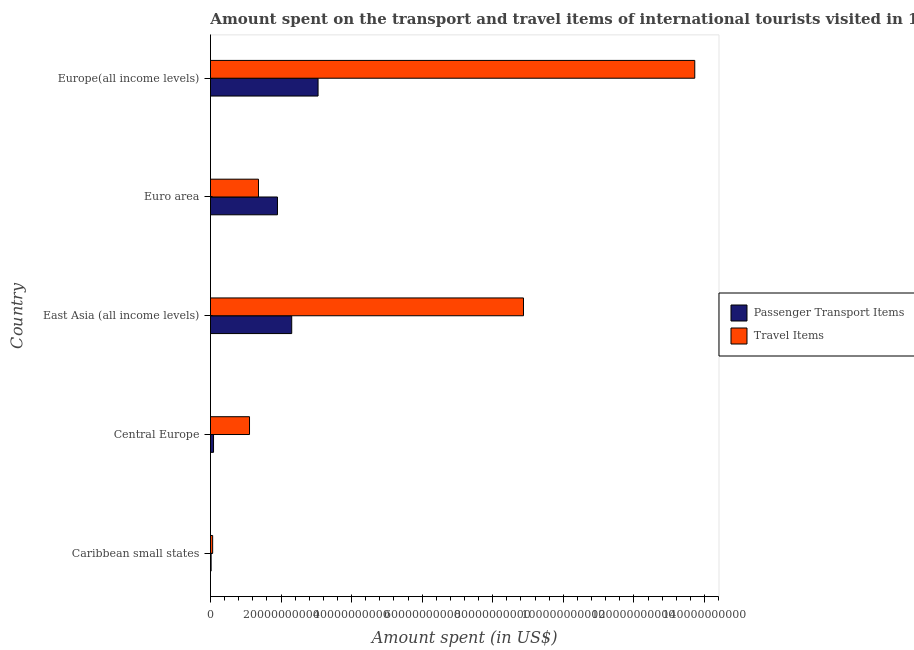How many groups of bars are there?
Ensure brevity in your answer.  5. How many bars are there on the 4th tick from the top?
Provide a short and direct response. 2. What is the label of the 4th group of bars from the top?
Offer a terse response. Central Europe. In how many cases, is the number of bars for a given country not equal to the number of legend labels?
Your response must be concise. 0. What is the amount spent in travel items in East Asia (all income levels)?
Keep it short and to the point. 8.87e+1. Across all countries, what is the maximum amount spent in travel items?
Keep it short and to the point. 1.37e+11. Across all countries, what is the minimum amount spent in travel items?
Your answer should be very brief. 6.17e+08. In which country was the amount spent in travel items maximum?
Keep it short and to the point. Europe(all income levels). In which country was the amount spent on passenger transport items minimum?
Offer a very short reply. Caribbean small states. What is the total amount spent on passenger transport items in the graph?
Keep it short and to the point. 7.35e+1. What is the difference between the amount spent in travel items in Euro area and that in Europe(all income levels)?
Your answer should be very brief. -1.24e+11. What is the difference between the amount spent on passenger transport items in Europe(all income levels) and the amount spent in travel items in Caribbean small states?
Your answer should be compact. 2.99e+1. What is the average amount spent on passenger transport items per country?
Ensure brevity in your answer.  1.47e+1. What is the difference between the amount spent in travel items and amount spent on passenger transport items in East Asia (all income levels)?
Offer a very short reply. 6.57e+1. In how many countries, is the amount spent in travel items greater than 32000000000 US$?
Offer a very short reply. 2. What is the ratio of the amount spent in travel items in East Asia (all income levels) to that in Europe(all income levels)?
Offer a terse response. 0.65. Is the difference between the amount spent on passenger transport items in Central Europe and Euro area greater than the difference between the amount spent in travel items in Central Europe and Euro area?
Keep it short and to the point. No. What is the difference between the highest and the second highest amount spent on passenger transport items?
Provide a short and direct response. 7.47e+09. What is the difference between the highest and the lowest amount spent on passenger transport items?
Keep it short and to the point. 3.03e+1. What does the 2nd bar from the top in Euro area represents?
Give a very brief answer. Passenger Transport Items. What does the 2nd bar from the bottom in Euro area represents?
Provide a short and direct response. Travel Items. How many bars are there?
Offer a very short reply. 10. Are all the bars in the graph horizontal?
Your answer should be very brief. Yes. How many countries are there in the graph?
Offer a terse response. 5. What is the difference between two consecutive major ticks on the X-axis?
Your answer should be very brief. 2.00e+1. Does the graph contain any zero values?
Your answer should be very brief. No. Does the graph contain grids?
Provide a short and direct response. No. Where does the legend appear in the graph?
Keep it short and to the point. Center right. How many legend labels are there?
Give a very brief answer. 2. How are the legend labels stacked?
Your response must be concise. Vertical. What is the title of the graph?
Give a very brief answer. Amount spent on the transport and travel items of international tourists visited in 1995. What is the label or title of the X-axis?
Your response must be concise. Amount spent (in US$). What is the label or title of the Y-axis?
Your response must be concise. Country. What is the Amount spent (in US$) in Passenger Transport Items in Caribbean small states?
Your answer should be compact. 1.79e+08. What is the Amount spent (in US$) of Travel Items in Caribbean small states?
Offer a very short reply. 6.17e+08. What is the Amount spent (in US$) of Passenger Transport Items in Central Europe?
Provide a short and direct response. 8.65e+08. What is the Amount spent (in US$) of Travel Items in Central Europe?
Offer a very short reply. 1.11e+1. What is the Amount spent (in US$) in Passenger Transport Items in East Asia (all income levels)?
Offer a terse response. 2.30e+1. What is the Amount spent (in US$) in Travel Items in East Asia (all income levels)?
Your answer should be very brief. 8.87e+1. What is the Amount spent (in US$) of Passenger Transport Items in Euro area?
Make the answer very short. 1.90e+1. What is the Amount spent (in US$) of Travel Items in Euro area?
Give a very brief answer. 1.36e+1. What is the Amount spent (in US$) of Passenger Transport Items in Europe(all income levels)?
Offer a very short reply. 3.05e+1. What is the Amount spent (in US$) of Travel Items in Europe(all income levels)?
Provide a short and direct response. 1.37e+11. Across all countries, what is the maximum Amount spent (in US$) in Passenger Transport Items?
Provide a succinct answer. 3.05e+1. Across all countries, what is the maximum Amount spent (in US$) of Travel Items?
Provide a short and direct response. 1.37e+11. Across all countries, what is the minimum Amount spent (in US$) of Passenger Transport Items?
Keep it short and to the point. 1.79e+08. Across all countries, what is the minimum Amount spent (in US$) in Travel Items?
Offer a very short reply. 6.17e+08. What is the total Amount spent (in US$) in Passenger Transport Items in the graph?
Your answer should be very brief. 7.35e+1. What is the total Amount spent (in US$) in Travel Items in the graph?
Provide a short and direct response. 2.51e+11. What is the difference between the Amount spent (in US$) in Passenger Transport Items in Caribbean small states and that in Central Europe?
Ensure brevity in your answer.  -6.86e+08. What is the difference between the Amount spent (in US$) of Travel Items in Caribbean small states and that in Central Europe?
Ensure brevity in your answer.  -1.04e+1. What is the difference between the Amount spent (in US$) in Passenger Transport Items in Caribbean small states and that in East Asia (all income levels)?
Your answer should be compact. -2.28e+1. What is the difference between the Amount spent (in US$) of Travel Items in Caribbean small states and that in East Asia (all income levels)?
Your answer should be very brief. -8.81e+1. What is the difference between the Amount spent (in US$) of Passenger Transport Items in Caribbean small states and that in Euro area?
Give a very brief answer. -1.88e+1. What is the difference between the Amount spent (in US$) in Travel Items in Caribbean small states and that in Euro area?
Your response must be concise. -1.30e+1. What is the difference between the Amount spent (in US$) in Passenger Transport Items in Caribbean small states and that in Europe(all income levels)?
Offer a very short reply. -3.03e+1. What is the difference between the Amount spent (in US$) in Travel Items in Caribbean small states and that in Europe(all income levels)?
Provide a succinct answer. -1.37e+11. What is the difference between the Amount spent (in US$) of Passenger Transport Items in Central Europe and that in East Asia (all income levels)?
Your answer should be very brief. -2.22e+1. What is the difference between the Amount spent (in US$) in Travel Items in Central Europe and that in East Asia (all income levels)?
Make the answer very short. -7.76e+1. What is the difference between the Amount spent (in US$) of Passenger Transport Items in Central Europe and that in Euro area?
Provide a succinct answer. -1.81e+1. What is the difference between the Amount spent (in US$) in Travel Items in Central Europe and that in Euro area?
Ensure brevity in your answer.  -2.54e+09. What is the difference between the Amount spent (in US$) in Passenger Transport Items in Central Europe and that in Europe(all income levels)?
Your answer should be compact. -2.96e+1. What is the difference between the Amount spent (in US$) of Travel Items in Central Europe and that in Europe(all income levels)?
Provide a succinct answer. -1.26e+11. What is the difference between the Amount spent (in US$) in Passenger Transport Items in East Asia (all income levels) and that in Euro area?
Ensure brevity in your answer.  4.04e+09. What is the difference between the Amount spent (in US$) in Travel Items in East Asia (all income levels) and that in Euro area?
Offer a terse response. 7.51e+1. What is the difference between the Amount spent (in US$) of Passenger Transport Items in East Asia (all income levels) and that in Europe(all income levels)?
Your answer should be very brief. -7.47e+09. What is the difference between the Amount spent (in US$) of Travel Items in East Asia (all income levels) and that in Europe(all income levels)?
Make the answer very short. -4.85e+1. What is the difference between the Amount spent (in US$) in Passenger Transport Items in Euro area and that in Europe(all income levels)?
Keep it short and to the point. -1.15e+1. What is the difference between the Amount spent (in US$) in Travel Items in Euro area and that in Europe(all income levels)?
Your answer should be compact. -1.24e+11. What is the difference between the Amount spent (in US$) of Passenger Transport Items in Caribbean small states and the Amount spent (in US$) of Travel Items in Central Europe?
Your answer should be compact. -1.09e+1. What is the difference between the Amount spent (in US$) of Passenger Transport Items in Caribbean small states and the Amount spent (in US$) of Travel Items in East Asia (all income levels)?
Provide a succinct answer. -8.85e+1. What is the difference between the Amount spent (in US$) of Passenger Transport Items in Caribbean small states and the Amount spent (in US$) of Travel Items in Euro area?
Keep it short and to the point. -1.34e+1. What is the difference between the Amount spent (in US$) of Passenger Transport Items in Caribbean small states and the Amount spent (in US$) of Travel Items in Europe(all income levels)?
Keep it short and to the point. -1.37e+11. What is the difference between the Amount spent (in US$) of Passenger Transport Items in Central Europe and the Amount spent (in US$) of Travel Items in East Asia (all income levels)?
Offer a very short reply. -8.78e+1. What is the difference between the Amount spent (in US$) in Passenger Transport Items in Central Europe and the Amount spent (in US$) in Travel Items in Euro area?
Your response must be concise. -1.27e+1. What is the difference between the Amount spent (in US$) in Passenger Transport Items in Central Europe and the Amount spent (in US$) in Travel Items in Europe(all income levels)?
Your response must be concise. -1.36e+11. What is the difference between the Amount spent (in US$) of Passenger Transport Items in East Asia (all income levels) and the Amount spent (in US$) of Travel Items in Euro area?
Offer a very short reply. 9.42e+09. What is the difference between the Amount spent (in US$) of Passenger Transport Items in East Asia (all income levels) and the Amount spent (in US$) of Travel Items in Europe(all income levels)?
Give a very brief answer. -1.14e+11. What is the difference between the Amount spent (in US$) of Passenger Transport Items in Euro area and the Amount spent (in US$) of Travel Items in Europe(all income levels)?
Give a very brief answer. -1.18e+11. What is the average Amount spent (in US$) in Passenger Transport Items per country?
Your response must be concise. 1.47e+1. What is the average Amount spent (in US$) of Travel Items per country?
Offer a very short reply. 5.02e+1. What is the difference between the Amount spent (in US$) in Passenger Transport Items and Amount spent (in US$) in Travel Items in Caribbean small states?
Offer a very short reply. -4.38e+08. What is the difference between the Amount spent (in US$) in Passenger Transport Items and Amount spent (in US$) in Travel Items in Central Europe?
Offer a terse response. -1.02e+1. What is the difference between the Amount spent (in US$) in Passenger Transport Items and Amount spent (in US$) in Travel Items in East Asia (all income levels)?
Provide a succinct answer. -6.57e+1. What is the difference between the Amount spent (in US$) in Passenger Transport Items and Amount spent (in US$) in Travel Items in Euro area?
Provide a short and direct response. 5.38e+09. What is the difference between the Amount spent (in US$) in Passenger Transport Items and Amount spent (in US$) in Travel Items in Europe(all income levels)?
Provide a short and direct response. -1.07e+11. What is the ratio of the Amount spent (in US$) of Passenger Transport Items in Caribbean small states to that in Central Europe?
Offer a terse response. 0.21. What is the ratio of the Amount spent (in US$) of Travel Items in Caribbean small states to that in Central Europe?
Make the answer very short. 0.06. What is the ratio of the Amount spent (in US$) of Passenger Transport Items in Caribbean small states to that in East Asia (all income levels)?
Offer a very short reply. 0.01. What is the ratio of the Amount spent (in US$) of Travel Items in Caribbean small states to that in East Asia (all income levels)?
Provide a short and direct response. 0.01. What is the ratio of the Amount spent (in US$) in Passenger Transport Items in Caribbean small states to that in Euro area?
Your answer should be very brief. 0.01. What is the ratio of the Amount spent (in US$) of Travel Items in Caribbean small states to that in Euro area?
Your response must be concise. 0.05. What is the ratio of the Amount spent (in US$) of Passenger Transport Items in Caribbean small states to that in Europe(all income levels)?
Your response must be concise. 0.01. What is the ratio of the Amount spent (in US$) in Travel Items in Caribbean small states to that in Europe(all income levels)?
Make the answer very short. 0. What is the ratio of the Amount spent (in US$) of Passenger Transport Items in Central Europe to that in East Asia (all income levels)?
Keep it short and to the point. 0.04. What is the ratio of the Amount spent (in US$) in Travel Items in Central Europe to that in East Asia (all income levels)?
Keep it short and to the point. 0.12. What is the ratio of the Amount spent (in US$) of Passenger Transport Items in Central Europe to that in Euro area?
Your response must be concise. 0.05. What is the ratio of the Amount spent (in US$) in Travel Items in Central Europe to that in Euro area?
Offer a terse response. 0.81. What is the ratio of the Amount spent (in US$) in Passenger Transport Items in Central Europe to that in Europe(all income levels)?
Make the answer very short. 0.03. What is the ratio of the Amount spent (in US$) in Travel Items in Central Europe to that in Europe(all income levels)?
Ensure brevity in your answer.  0.08. What is the ratio of the Amount spent (in US$) of Passenger Transport Items in East Asia (all income levels) to that in Euro area?
Make the answer very short. 1.21. What is the ratio of the Amount spent (in US$) in Travel Items in East Asia (all income levels) to that in Euro area?
Your answer should be very brief. 6.52. What is the ratio of the Amount spent (in US$) of Passenger Transport Items in East Asia (all income levels) to that in Europe(all income levels)?
Offer a very short reply. 0.76. What is the ratio of the Amount spent (in US$) of Travel Items in East Asia (all income levels) to that in Europe(all income levels)?
Give a very brief answer. 0.65. What is the ratio of the Amount spent (in US$) of Passenger Transport Items in Euro area to that in Europe(all income levels)?
Your response must be concise. 0.62. What is the ratio of the Amount spent (in US$) of Travel Items in Euro area to that in Europe(all income levels)?
Offer a very short reply. 0.1. What is the difference between the highest and the second highest Amount spent (in US$) of Passenger Transport Items?
Provide a succinct answer. 7.47e+09. What is the difference between the highest and the second highest Amount spent (in US$) in Travel Items?
Your response must be concise. 4.85e+1. What is the difference between the highest and the lowest Amount spent (in US$) in Passenger Transport Items?
Provide a succinct answer. 3.03e+1. What is the difference between the highest and the lowest Amount spent (in US$) of Travel Items?
Offer a terse response. 1.37e+11. 